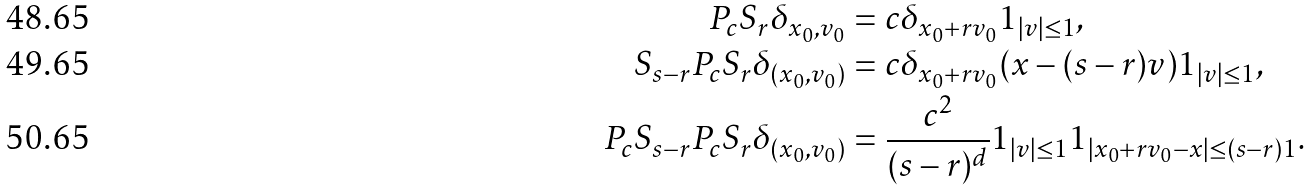<formula> <loc_0><loc_0><loc_500><loc_500>P _ { c } S _ { r } \delta _ { x _ { 0 } , v _ { 0 } } & = c \delta _ { x _ { 0 } + r v _ { 0 } } 1 _ { | v | \leq 1 } , \\ S _ { s - r } P _ { c } S _ { r } \delta _ { ( x _ { 0 } , v _ { 0 } ) } & = c \delta _ { x _ { 0 } + r v _ { 0 } } ( x - ( s - r ) v ) 1 _ { | v | \leq 1 } , \\ P _ { c } S _ { s - r } P _ { c } S _ { r } \delta _ { ( x _ { 0 } , v _ { 0 } ) } & = \frac { c ^ { 2 } } { ( s - r ) ^ { d } } 1 _ { | v | \leq 1 } 1 _ { | x _ { 0 } + r v _ { 0 } - x | \leq ( s - r ) 1 } .</formula> 